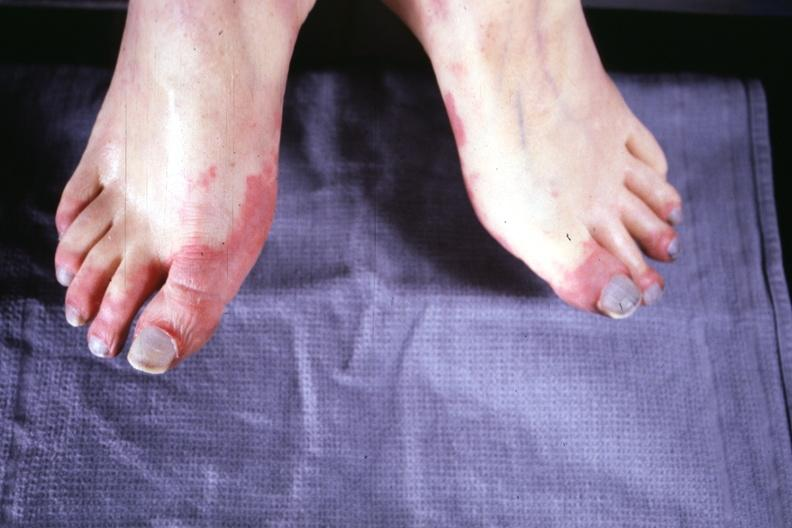s x-ray intramyocardial arteries present?
Answer the question using a single word or phrase. No 